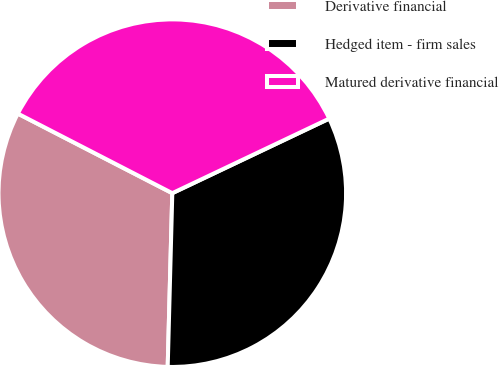<chart> <loc_0><loc_0><loc_500><loc_500><pie_chart><fcel>Derivative financial<fcel>Hedged item - firm sales<fcel>Matured derivative financial<nl><fcel>32.15%<fcel>32.48%<fcel>35.37%<nl></chart> 